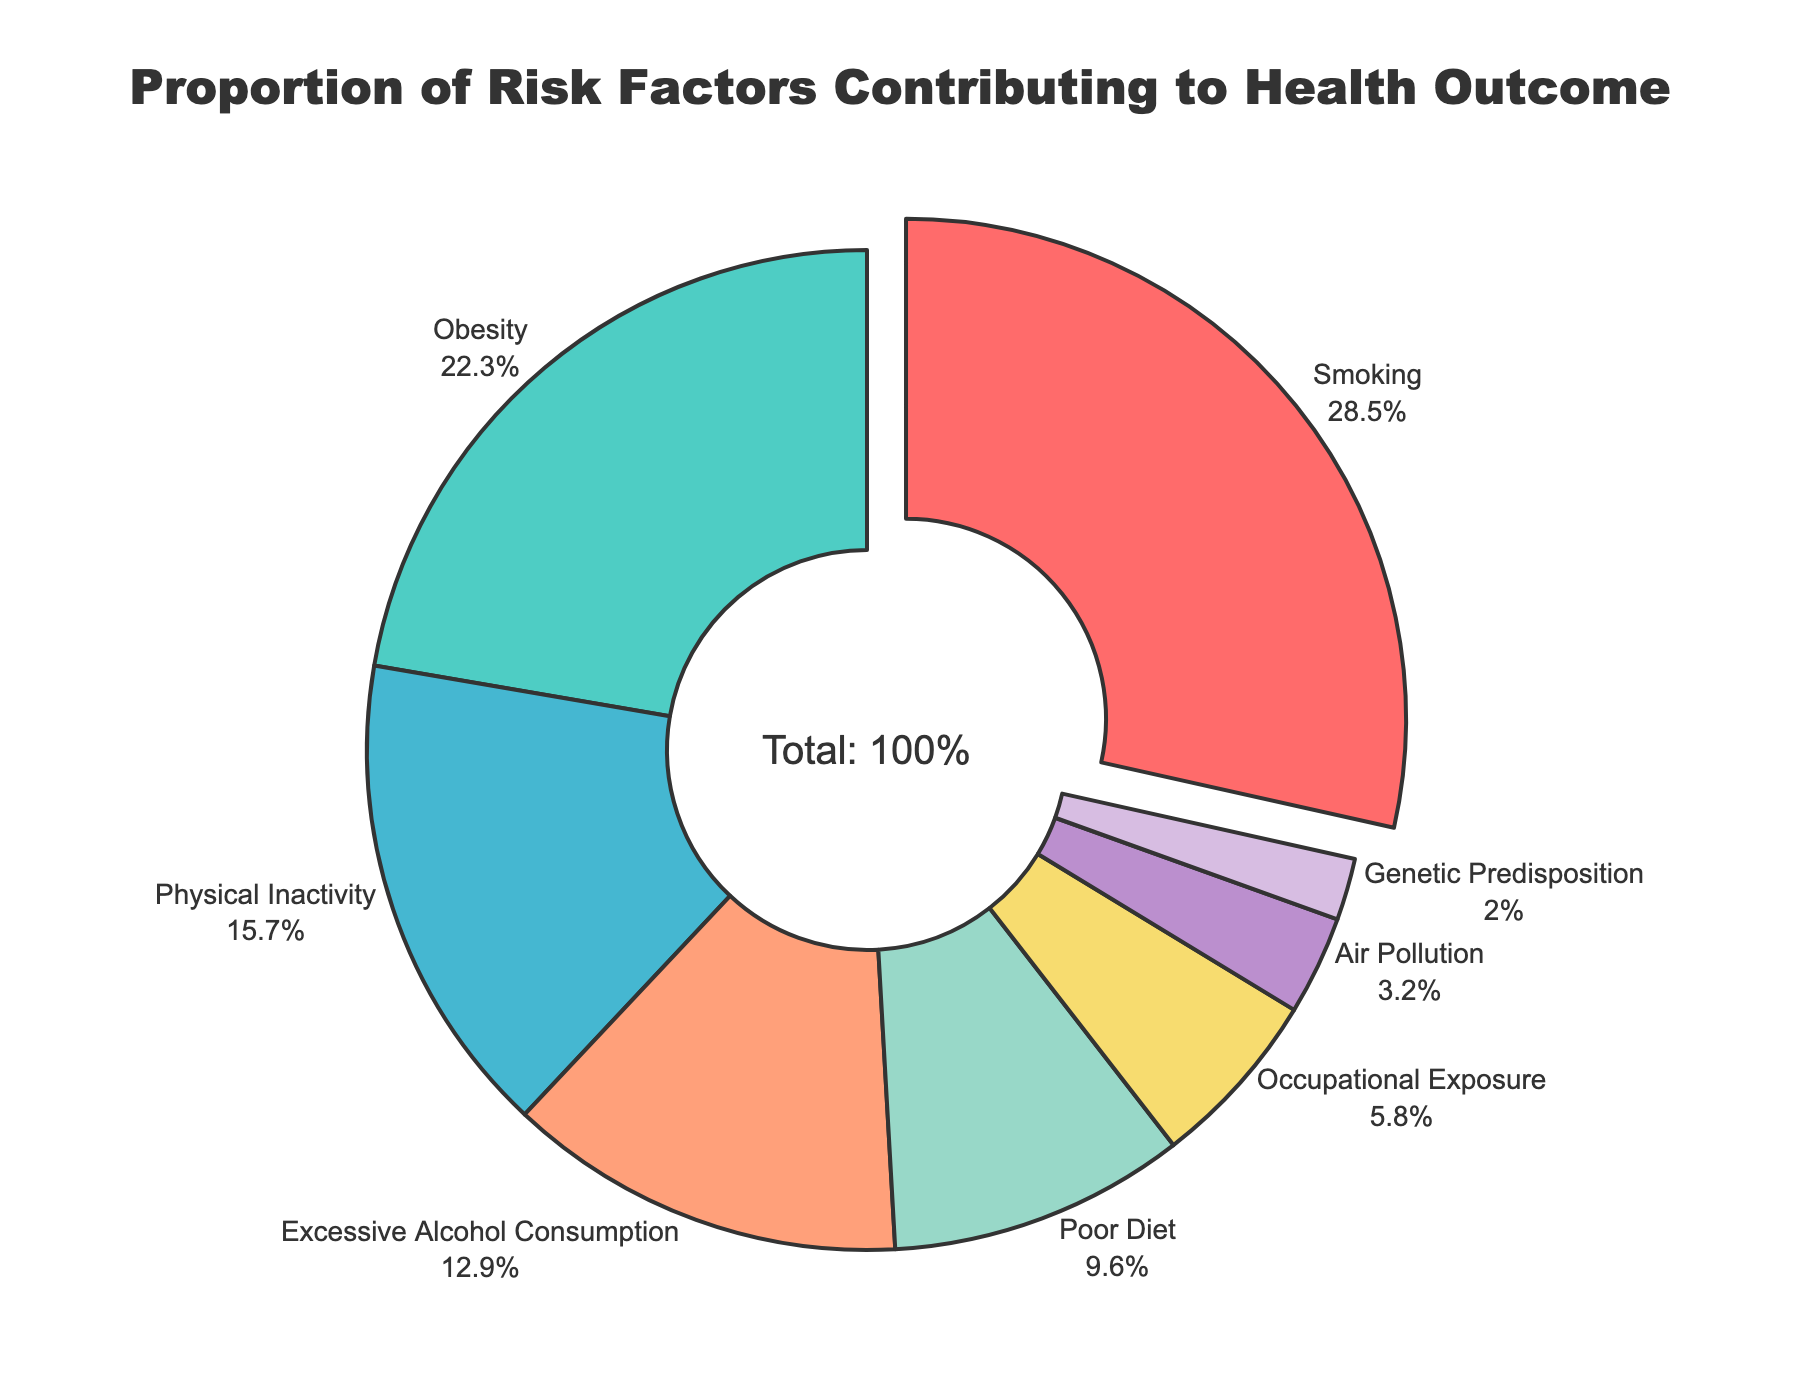What is the proportion of the leading risk factor contributing to the health outcome? The pie chart shows that smoking is the leading risk factor, marked by a segment that is slightly pulled out. Smoking contributes 28.5% to the health outcome.
Answer: 28.5% Which risk factor has the smallest contribution to the health outcome? By observing the segments in the pie chart, the smallest segment corresponds to Genetic Predisposition, which contributes 2.0%.
Answer: 2.0% What are the total contributions of Obesity and Physical Inactivity? The chart shows that Obesity contributes 22.3% and Physical Inactivity contributes 15.7%. The combined total is 22.3% + 15.7% = 38.0%.
Answer: 38.0% Compare the contributions of Excessive Alcohol Consumption and Poor Diet. Which one is higher and by how much? Excessive Alcohol Consumption contributes 12.9%, while Poor Diet contributes 9.6%. Therefore, Excessive Alcohol Consumption is higher by 12.9% - 9.6% = 3.3%.
Answer: 3.3% What proportion of the health outcome is contributed by Environmental and Occupational factors combined? Air Pollution contributes 3.2% and Occupational Exposure contributes 5.8%. Adding these gives 3.2% + 5.8% = 9.0%.
Answer: 9.0% Which risk factor is depicted in red and what is its proportion? The pie chart shows that the segment in red corresponds to Smoking, which contributes 28.5%.
Answer: Smoking, 28.5% What is the difference in contribution between the highest and lowest risk factors? The highest contributing risk factor is Smoking at 28.5%, and the lowest is Genetic Predisposition at 2.0%. The difference is 28.5% - 2.0% = 26.5%.
Answer: 26.5% Combine the contributions of the two least contributing risk factors. What is their total proportion? The two least contributing risk factors are Genetic Predisposition (2.0%) and Air Pollution (3.2%). Their combined proportion is 2.0% + 3.2% = 5.2%.
Answer: 5.2% Which risk factors combined contribute more than 50% to the health outcome? Adding Smoking (28.5%), Obesity (22.3%), and Physical Inactivity (15.7%) gives 28.5% + 22.3% + 15.7% = 66.5%, which is greater than 50%, and these are the top three contributing factors.
Answer: Smoking, Obesity, Physical Inactivity How much more does Smoking contribute compared to Occupational Exposure? Smoking contributes 28.5%, while Occupational Exposure contributes 5.8%. The difference is 28.5% - 5.8% = 22.7%.
Answer: 22.7% 